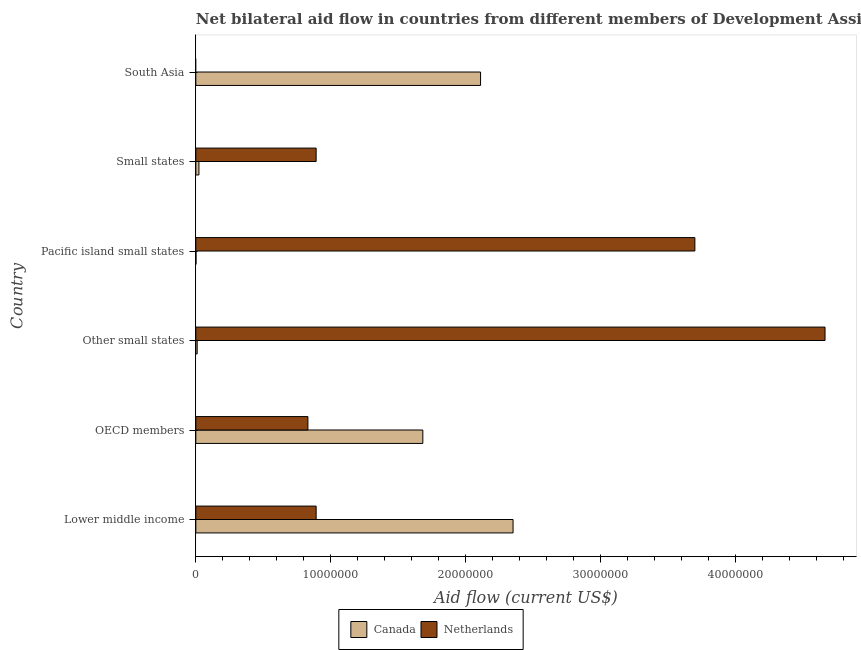How many different coloured bars are there?
Make the answer very short. 2. Are the number of bars per tick equal to the number of legend labels?
Offer a very short reply. No. Are the number of bars on each tick of the Y-axis equal?
Offer a terse response. No. How many bars are there on the 1st tick from the top?
Your answer should be very brief. 1. How many bars are there on the 6th tick from the bottom?
Provide a succinct answer. 1. In how many cases, is the number of bars for a given country not equal to the number of legend labels?
Your answer should be very brief. 1. What is the amount of aid given by canada in OECD members?
Offer a terse response. 1.68e+07. Across all countries, what is the maximum amount of aid given by netherlands?
Your answer should be very brief. 4.66e+07. Across all countries, what is the minimum amount of aid given by canada?
Give a very brief answer. 10000. In which country was the amount of aid given by canada maximum?
Provide a succinct answer. Lower middle income. What is the total amount of aid given by canada in the graph?
Provide a short and direct response. 6.18e+07. What is the difference between the amount of aid given by canada in Lower middle income and that in Small states?
Offer a very short reply. 2.33e+07. What is the difference between the amount of aid given by netherlands in South Asia and the amount of aid given by canada in Small states?
Your answer should be compact. -2.30e+05. What is the average amount of aid given by netherlands per country?
Provide a short and direct response. 1.83e+07. What is the difference between the amount of aid given by canada and amount of aid given by netherlands in Small states?
Provide a succinct answer. -8.69e+06. In how many countries, is the amount of aid given by netherlands greater than 22000000 US$?
Provide a short and direct response. 2. What is the ratio of the amount of aid given by canada in Pacific island small states to that in Small states?
Ensure brevity in your answer.  0.04. Is the difference between the amount of aid given by canada in OECD members and Other small states greater than the difference between the amount of aid given by netherlands in OECD members and Other small states?
Give a very brief answer. Yes. What is the difference between the highest and the second highest amount of aid given by netherlands?
Your response must be concise. 9.65e+06. What is the difference between the highest and the lowest amount of aid given by canada?
Make the answer very short. 2.35e+07. In how many countries, is the amount of aid given by canada greater than the average amount of aid given by canada taken over all countries?
Your answer should be compact. 3. How many countries are there in the graph?
Your response must be concise. 6. What is the difference between two consecutive major ticks on the X-axis?
Provide a short and direct response. 1.00e+07. Are the values on the major ticks of X-axis written in scientific E-notation?
Make the answer very short. No. Does the graph contain any zero values?
Provide a short and direct response. Yes. Where does the legend appear in the graph?
Keep it short and to the point. Bottom center. How are the legend labels stacked?
Your answer should be compact. Horizontal. What is the title of the graph?
Ensure brevity in your answer.  Net bilateral aid flow in countries from different members of Development Assistance Committee. What is the label or title of the X-axis?
Offer a terse response. Aid flow (current US$). What is the Aid flow (current US$) in Canada in Lower middle income?
Make the answer very short. 2.35e+07. What is the Aid flow (current US$) in Netherlands in Lower middle income?
Give a very brief answer. 8.92e+06. What is the Aid flow (current US$) in Canada in OECD members?
Make the answer very short. 1.68e+07. What is the Aid flow (current US$) in Netherlands in OECD members?
Offer a terse response. 8.31e+06. What is the Aid flow (current US$) in Canada in Other small states?
Your response must be concise. 1.00e+05. What is the Aid flow (current US$) in Netherlands in Other small states?
Give a very brief answer. 4.66e+07. What is the Aid flow (current US$) in Netherlands in Pacific island small states?
Offer a terse response. 3.70e+07. What is the Aid flow (current US$) of Netherlands in Small states?
Make the answer very short. 8.92e+06. What is the Aid flow (current US$) of Canada in South Asia?
Provide a succinct answer. 2.11e+07. What is the Aid flow (current US$) of Netherlands in South Asia?
Ensure brevity in your answer.  0. Across all countries, what is the maximum Aid flow (current US$) in Canada?
Ensure brevity in your answer.  2.35e+07. Across all countries, what is the maximum Aid flow (current US$) of Netherlands?
Your response must be concise. 4.66e+07. Across all countries, what is the minimum Aid flow (current US$) of Canada?
Provide a succinct answer. 10000. Across all countries, what is the minimum Aid flow (current US$) in Netherlands?
Your answer should be very brief. 0. What is the total Aid flow (current US$) in Canada in the graph?
Offer a terse response. 6.18e+07. What is the total Aid flow (current US$) in Netherlands in the graph?
Provide a succinct answer. 1.10e+08. What is the difference between the Aid flow (current US$) of Canada in Lower middle income and that in OECD members?
Offer a very short reply. 6.69e+06. What is the difference between the Aid flow (current US$) in Netherlands in Lower middle income and that in OECD members?
Provide a short and direct response. 6.10e+05. What is the difference between the Aid flow (current US$) in Canada in Lower middle income and that in Other small states?
Provide a succinct answer. 2.34e+07. What is the difference between the Aid flow (current US$) in Netherlands in Lower middle income and that in Other small states?
Provide a short and direct response. -3.77e+07. What is the difference between the Aid flow (current US$) in Canada in Lower middle income and that in Pacific island small states?
Provide a short and direct response. 2.35e+07. What is the difference between the Aid flow (current US$) of Netherlands in Lower middle income and that in Pacific island small states?
Make the answer very short. -2.81e+07. What is the difference between the Aid flow (current US$) in Canada in Lower middle income and that in Small states?
Keep it short and to the point. 2.33e+07. What is the difference between the Aid flow (current US$) of Netherlands in Lower middle income and that in Small states?
Give a very brief answer. 0. What is the difference between the Aid flow (current US$) in Canada in Lower middle income and that in South Asia?
Your response must be concise. 2.41e+06. What is the difference between the Aid flow (current US$) of Canada in OECD members and that in Other small states?
Keep it short and to the point. 1.67e+07. What is the difference between the Aid flow (current US$) in Netherlands in OECD members and that in Other small states?
Your response must be concise. -3.83e+07. What is the difference between the Aid flow (current US$) in Canada in OECD members and that in Pacific island small states?
Give a very brief answer. 1.68e+07. What is the difference between the Aid flow (current US$) in Netherlands in OECD members and that in Pacific island small states?
Provide a short and direct response. -2.87e+07. What is the difference between the Aid flow (current US$) of Canada in OECD members and that in Small states?
Keep it short and to the point. 1.66e+07. What is the difference between the Aid flow (current US$) in Netherlands in OECD members and that in Small states?
Give a very brief answer. -6.10e+05. What is the difference between the Aid flow (current US$) in Canada in OECD members and that in South Asia?
Your answer should be very brief. -4.28e+06. What is the difference between the Aid flow (current US$) of Canada in Other small states and that in Pacific island small states?
Offer a very short reply. 9.00e+04. What is the difference between the Aid flow (current US$) of Netherlands in Other small states and that in Pacific island small states?
Your response must be concise. 9.65e+06. What is the difference between the Aid flow (current US$) of Netherlands in Other small states and that in Small states?
Make the answer very short. 3.77e+07. What is the difference between the Aid flow (current US$) of Canada in Other small states and that in South Asia?
Your answer should be compact. -2.10e+07. What is the difference between the Aid flow (current US$) of Netherlands in Pacific island small states and that in Small states?
Offer a terse response. 2.81e+07. What is the difference between the Aid flow (current US$) of Canada in Pacific island small states and that in South Asia?
Your answer should be compact. -2.11e+07. What is the difference between the Aid flow (current US$) in Canada in Small states and that in South Asia?
Provide a short and direct response. -2.09e+07. What is the difference between the Aid flow (current US$) in Canada in Lower middle income and the Aid flow (current US$) in Netherlands in OECD members?
Provide a succinct answer. 1.52e+07. What is the difference between the Aid flow (current US$) of Canada in Lower middle income and the Aid flow (current US$) of Netherlands in Other small states?
Offer a terse response. -2.31e+07. What is the difference between the Aid flow (current US$) in Canada in Lower middle income and the Aid flow (current US$) in Netherlands in Pacific island small states?
Make the answer very short. -1.35e+07. What is the difference between the Aid flow (current US$) of Canada in Lower middle income and the Aid flow (current US$) of Netherlands in Small states?
Give a very brief answer. 1.46e+07. What is the difference between the Aid flow (current US$) of Canada in OECD members and the Aid flow (current US$) of Netherlands in Other small states?
Your response must be concise. -2.98e+07. What is the difference between the Aid flow (current US$) of Canada in OECD members and the Aid flow (current US$) of Netherlands in Pacific island small states?
Your response must be concise. -2.02e+07. What is the difference between the Aid flow (current US$) in Canada in OECD members and the Aid flow (current US$) in Netherlands in Small states?
Make the answer very short. 7.91e+06. What is the difference between the Aid flow (current US$) of Canada in Other small states and the Aid flow (current US$) of Netherlands in Pacific island small states?
Offer a very short reply. -3.69e+07. What is the difference between the Aid flow (current US$) in Canada in Other small states and the Aid flow (current US$) in Netherlands in Small states?
Your response must be concise. -8.82e+06. What is the difference between the Aid flow (current US$) in Canada in Pacific island small states and the Aid flow (current US$) in Netherlands in Small states?
Make the answer very short. -8.91e+06. What is the average Aid flow (current US$) of Canada per country?
Provide a short and direct response. 1.03e+07. What is the average Aid flow (current US$) in Netherlands per country?
Your response must be concise. 1.83e+07. What is the difference between the Aid flow (current US$) of Canada and Aid flow (current US$) of Netherlands in Lower middle income?
Provide a short and direct response. 1.46e+07. What is the difference between the Aid flow (current US$) of Canada and Aid flow (current US$) of Netherlands in OECD members?
Offer a terse response. 8.52e+06. What is the difference between the Aid flow (current US$) in Canada and Aid flow (current US$) in Netherlands in Other small states?
Make the answer very short. -4.66e+07. What is the difference between the Aid flow (current US$) of Canada and Aid flow (current US$) of Netherlands in Pacific island small states?
Your response must be concise. -3.70e+07. What is the difference between the Aid flow (current US$) of Canada and Aid flow (current US$) of Netherlands in Small states?
Offer a very short reply. -8.69e+06. What is the ratio of the Aid flow (current US$) of Canada in Lower middle income to that in OECD members?
Offer a terse response. 1.4. What is the ratio of the Aid flow (current US$) of Netherlands in Lower middle income to that in OECD members?
Provide a short and direct response. 1.07. What is the ratio of the Aid flow (current US$) of Canada in Lower middle income to that in Other small states?
Ensure brevity in your answer.  235.2. What is the ratio of the Aid flow (current US$) of Netherlands in Lower middle income to that in Other small states?
Your answer should be very brief. 0.19. What is the ratio of the Aid flow (current US$) in Canada in Lower middle income to that in Pacific island small states?
Your answer should be very brief. 2352. What is the ratio of the Aid flow (current US$) in Netherlands in Lower middle income to that in Pacific island small states?
Offer a very short reply. 0.24. What is the ratio of the Aid flow (current US$) of Canada in Lower middle income to that in Small states?
Your answer should be compact. 102.26. What is the ratio of the Aid flow (current US$) of Netherlands in Lower middle income to that in Small states?
Your answer should be compact. 1. What is the ratio of the Aid flow (current US$) of Canada in Lower middle income to that in South Asia?
Your answer should be compact. 1.11. What is the ratio of the Aid flow (current US$) in Canada in OECD members to that in Other small states?
Ensure brevity in your answer.  168.3. What is the ratio of the Aid flow (current US$) in Netherlands in OECD members to that in Other small states?
Offer a very short reply. 0.18. What is the ratio of the Aid flow (current US$) in Canada in OECD members to that in Pacific island small states?
Provide a short and direct response. 1683. What is the ratio of the Aid flow (current US$) in Netherlands in OECD members to that in Pacific island small states?
Ensure brevity in your answer.  0.22. What is the ratio of the Aid flow (current US$) in Canada in OECD members to that in Small states?
Make the answer very short. 73.17. What is the ratio of the Aid flow (current US$) in Netherlands in OECD members to that in Small states?
Offer a very short reply. 0.93. What is the ratio of the Aid flow (current US$) of Canada in OECD members to that in South Asia?
Give a very brief answer. 0.8. What is the ratio of the Aid flow (current US$) in Netherlands in Other small states to that in Pacific island small states?
Your response must be concise. 1.26. What is the ratio of the Aid flow (current US$) of Canada in Other small states to that in Small states?
Offer a very short reply. 0.43. What is the ratio of the Aid flow (current US$) of Netherlands in Other small states to that in Small states?
Your answer should be very brief. 5.23. What is the ratio of the Aid flow (current US$) of Canada in Other small states to that in South Asia?
Provide a short and direct response. 0. What is the ratio of the Aid flow (current US$) in Canada in Pacific island small states to that in Small states?
Your answer should be very brief. 0.04. What is the ratio of the Aid flow (current US$) of Netherlands in Pacific island small states to that in Small states?
Your answer should be compact. 4.15. What is the ratio of the Aid flow (current US$) of Canada in Pacific island small states to that in South Asia?
Provide a short and direct response. 0. What is the ratio of the Aid flow (current US$) in Canada in Small states to that in South Asia?
Provide a short and direct response. 0.01. What is the difference between the highest and the second highest Aid flow (current US$) of Canada?
Offer a terse response. 2.41e+06. What is the difference between the highest and the second highest Aid flow (current US$) of Netherlands?
Keep it short and to the point. 9.65e+06. What is the difference between the highest and the lowest Aid flow (current US$) of Canada?
Keep it short and to the point. 2.35e+07. What is the difference between the highest and the lowest Aid flow (current US$) in Netherlands?
Your response must be concise. 4.66e+07. 